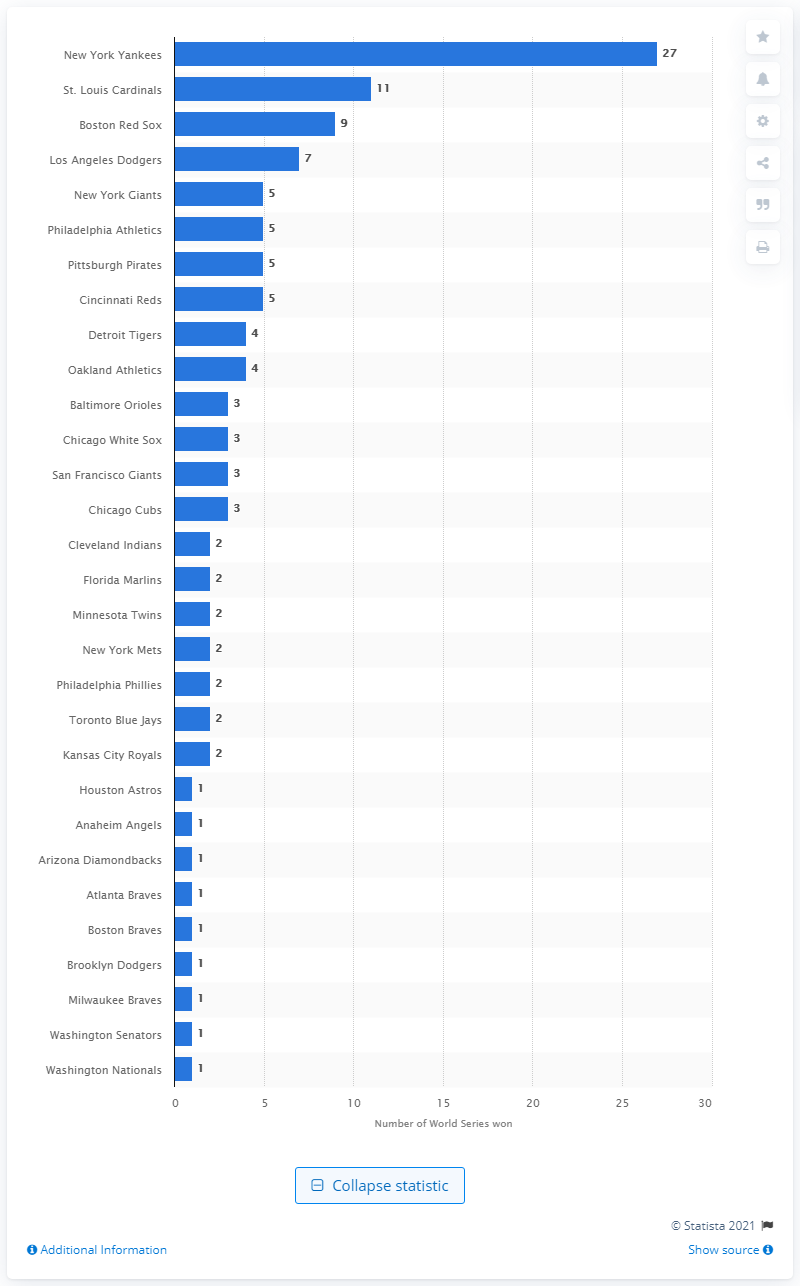Point out several critical features in this image. The St. Louis Cardinals have won the World Series 11 times, making them the team with the most victorious titles in the prestigious competition. The New York Yankees have won the World Series a remarkable 27 times. 